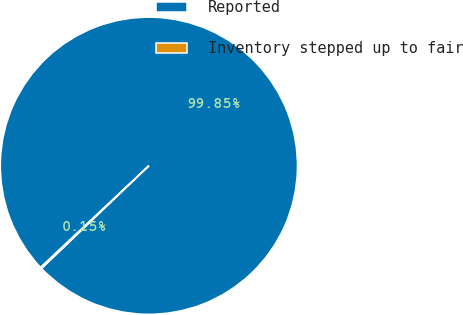<chart> <loc_0><loc_0><loc_500><loc_500><pie_chart><fcel>Reported<fcel>Inventory stepped up to fair<nl><fcel>99.85%<fcel>0.15%<nl></chart> 